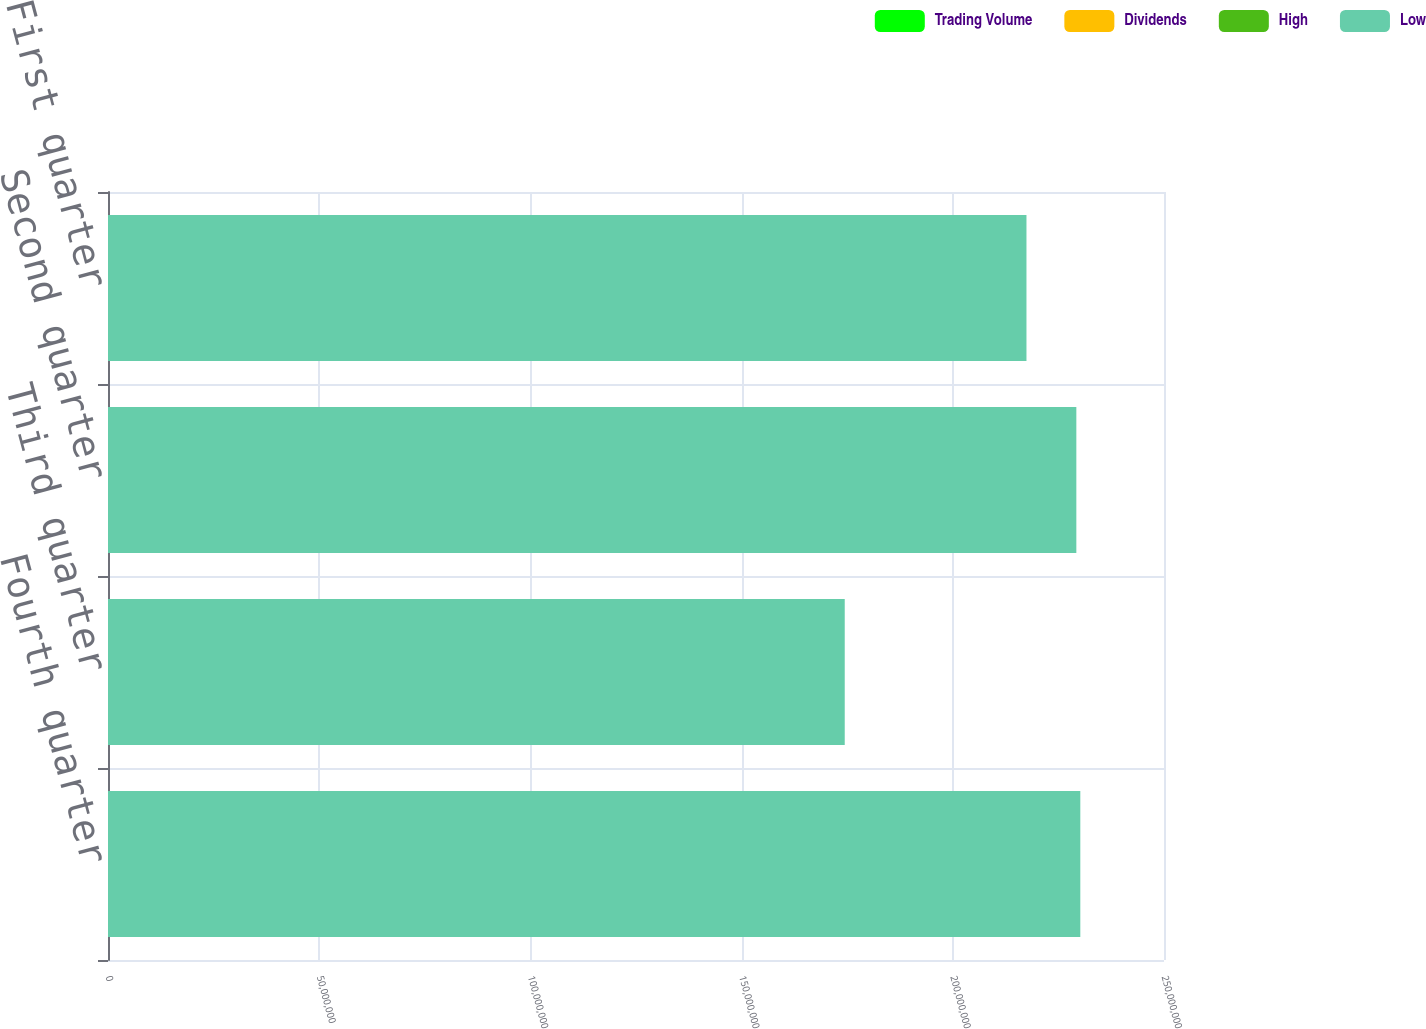Convert chart to OTSL. <chart><loc_0><loc_0><loc_500><loc_500><stacked_bar_chart><ecel><fcel>Fourth quarter<fcel>Third quarter<fcel>Second quarter<fcel>First quarter<nl><fcel>Trading Volume<fcel>50.63<fcel>47.21<fcel>52.87<fcel>59.2<nl><fcel>Dividends<fcel>39.65<fcel>38.98<fcel>39.96<fcel>42.76<nl><fcel>High<fcel>0.8<fcel>0.8<fcel>0.8<fcel>0.8<nl><fcel>Low<fcel>2.30187e+08<fcel>1.74417e+08<fcel>2.29247e+08<fcel>2.1744e+08<nl></chart> 